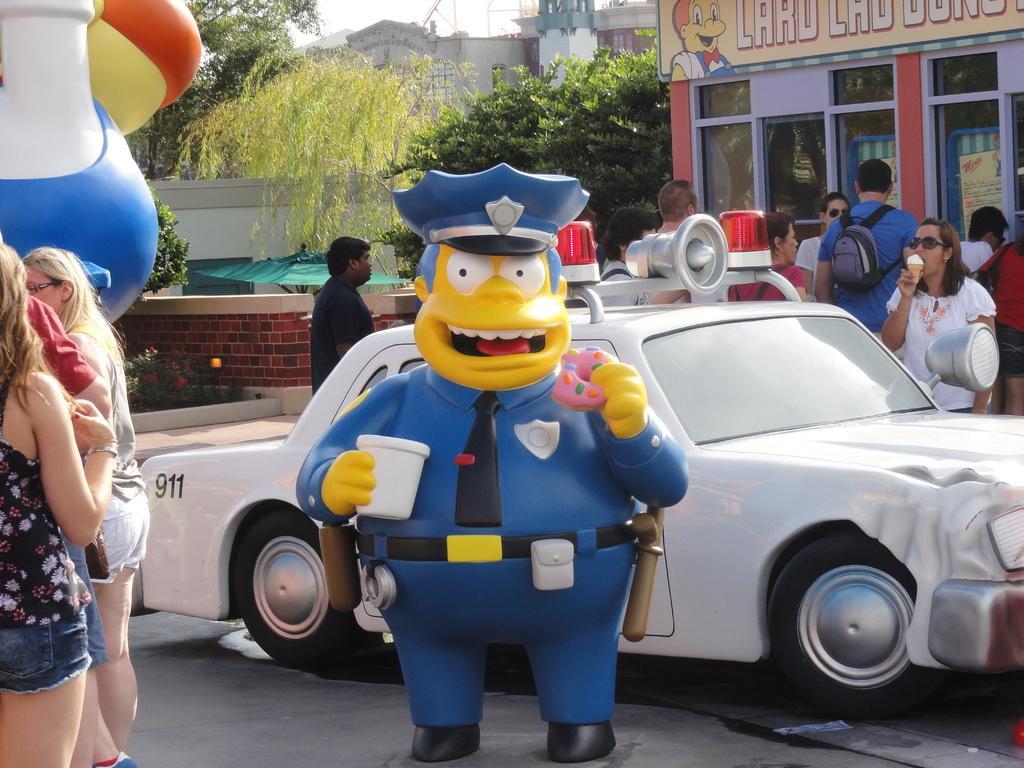In one or two sentences, can you explain what this image depicts? In this picture we can see vehicle,people on the road and in the background we can see buildings,trees. 